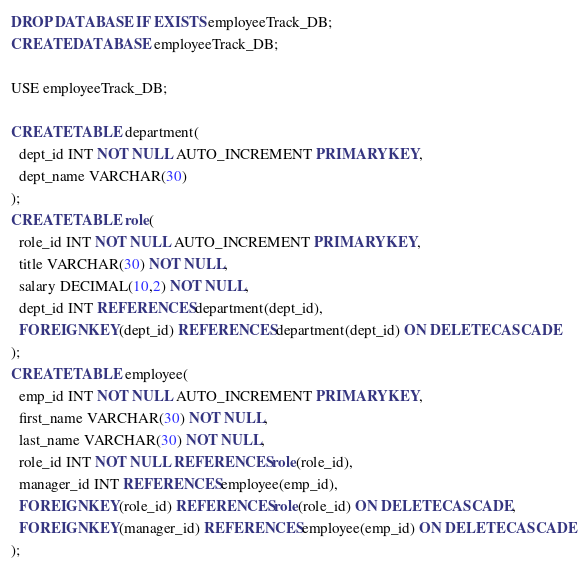<code> <loc_0><loc_0><loc_500><loc_500><_SQL_>DROP DATABASE IF EXISTS employeeTrack_DB;
CREATE DATABASE employeeTrack_DB;

USE employeeTrack_DB;

CREATE TABLE department(
  dept_id INT NOT NULL AUTO_INCREMENT PRIMARY KEY,
  dept_name VARCHAR(30)
);
CREATE TABLE role(
  role_id INT NOT NULL AUTO_INCREMENT PRIMARY KEY,
  title VARCHAR(30) NOT NULL,
  salary DECIMAL(10,2) NOT NULL,
  dept_id INT REFERENCES department(dept_id),
  FOREIGN KEY(dept_id) REFERENCES department(dept_id) ON DELETE CASCADE
);
CREATE TABLE employee(
  emp_id INT NOT NULL AUTO_INCREMENT PRIMARY KEY,
  first_name VARCHAR(30) NOT NULL,
  last_name VARCHAR(30) NOT NULL,
  role_id INT NOT NULL REFERENCES role(role_id),
  manager_id INT REFERENCES employee(emp_id),
  FOREIGN KEY(role_id) REFERENCES role(role_id) ON DELETE CASCADE,
  FOREIGN KEY(manager_id) REFERENCES employee(emp_id) ON DELETE CASCADE
);

</code> 